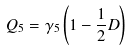<formula> <loc_0><loc_0><loc_500><loc_500>Q _ { 5 } = \gamma _ { 5 } \left ( 1 - \frac { 1 } { 2 } D \right )</formula> 